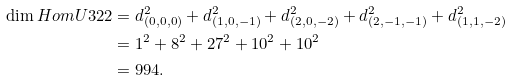Convert formula to latex. <formula><loc_0><loc_0><loc_500><loc_500>\dim H o m U { 3 } { 2 } { 2 } & = d _ { ( 0 , 0 , 0 ) } ^ { 2 } + d _ { ( 1 , 0 , - 1 ) } ^ { 2 } + d _ { ( 2 , 0 , - 2 ) } ^ { 2 } + d _ { ( 2 , - 1 , - 1 ) } ^ { 2 } + d _ { ( 1 , 1 , - 2 ) } ^ { 2 } \\ & = 1 ^ { 2 } + 8 ^ { 2 } + 2 7 ^ { 2 } + 1 0 ^ { 2 } + 1 0 ^ { 2 } \\ & = 9 9 4 .</formula> 